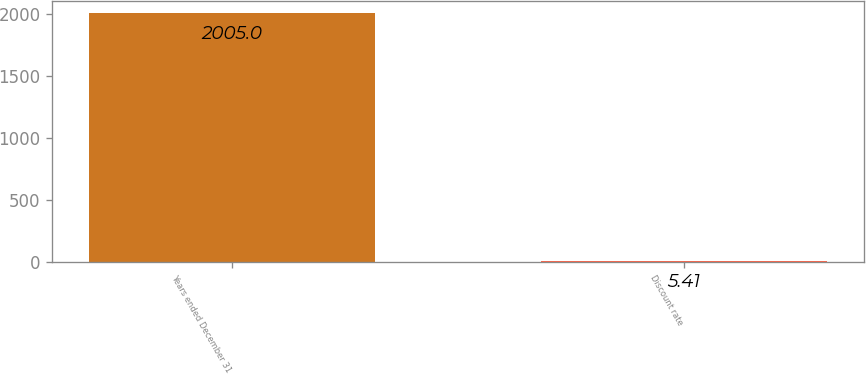Convert chart. <chart><loc_0><loc_0><loc_500><loc_500><bar_chart><fcel>Years ended December 31<fcel>Discount rate<nl><fcel>2005<fcel>5.41<nl></chart> 